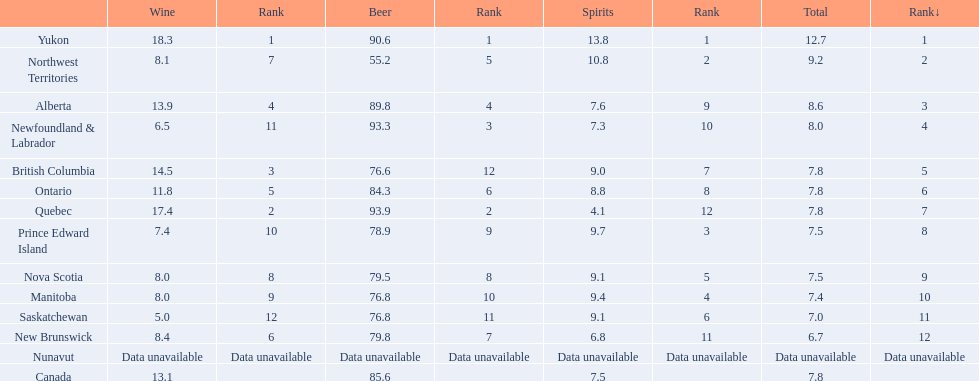Which territory in canada consumed 93.9 units of beer? Quebec. What was their spirits consumption? 4.1. 